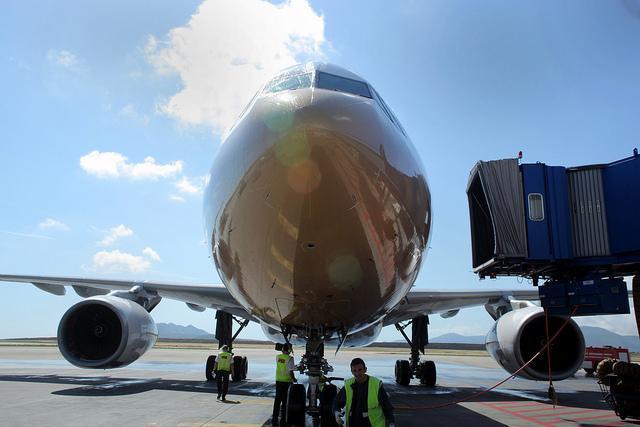How many people are around the plane?
Give a very brief answer. 3. How many workers are there on the plane?
Give a very brief answer. 3. 